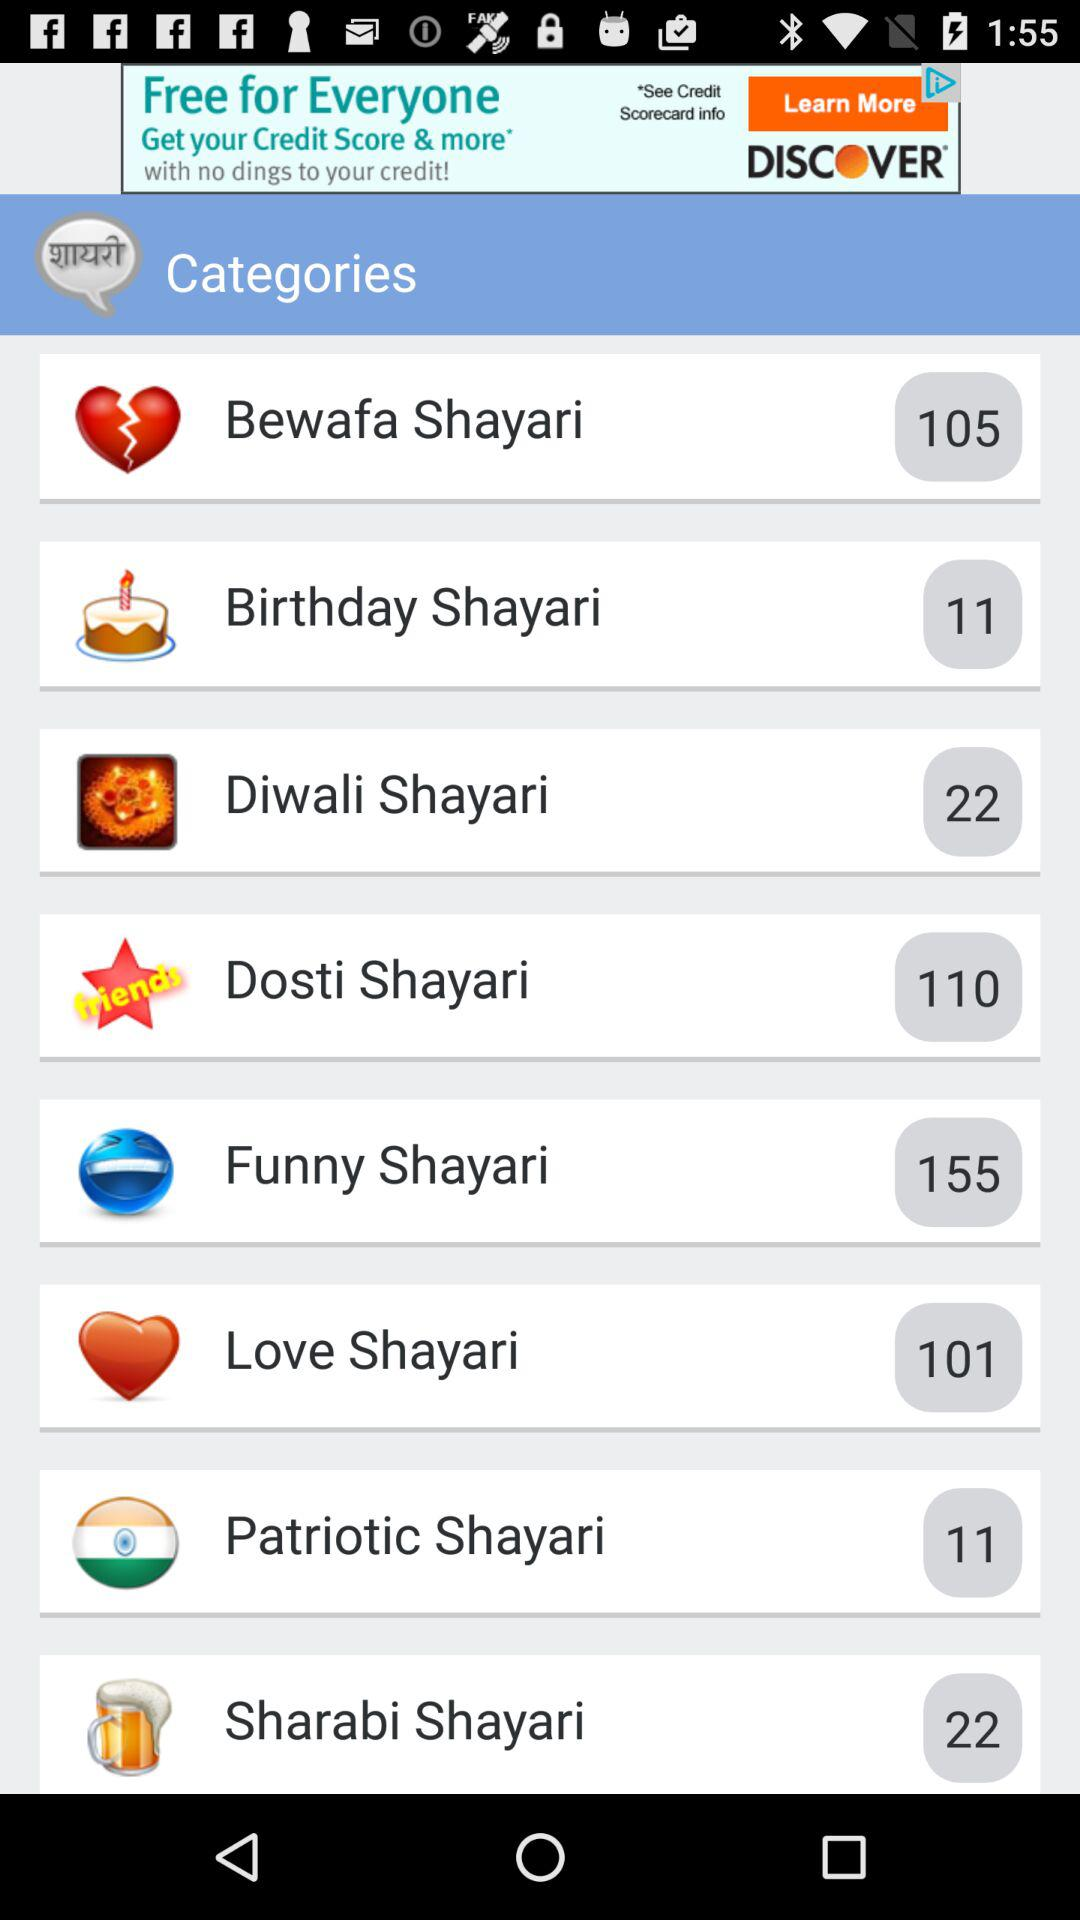What is the number of patriotic shayari? The number of patriotic shayari is 11. 